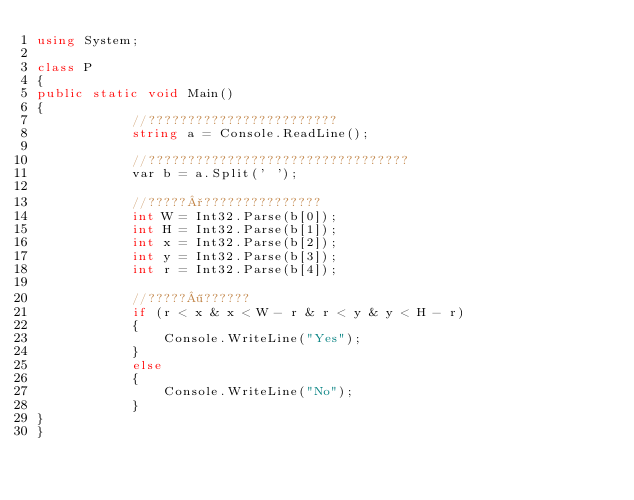Convert code to text. <code><loc_0><loc_0><loc_500><loc_500><_C#_>using System;

class P
{
public static void Main()
{
            //????????????????????????
            string a = Console.ReadLine();

            //?????????????????????????????????
            var b = a.Split(' ');

            //?????°???????????????
            int W = Int32.Parse(b[0]);
            int H = Int32.Parse(b[1]);
            int x = Int32.Parse(b[2]);
            int y = Int32.Parse(b[3]);
            int r = Int32.Parse(b[4]);

            //?????¶??????
            if (r < x & x < W - r & r < y & y < H - r)
            {
                Console.WriteLine("Yes");
            }
            else
            {
                Console.WriteLine("No");
            }
}
}</code> 